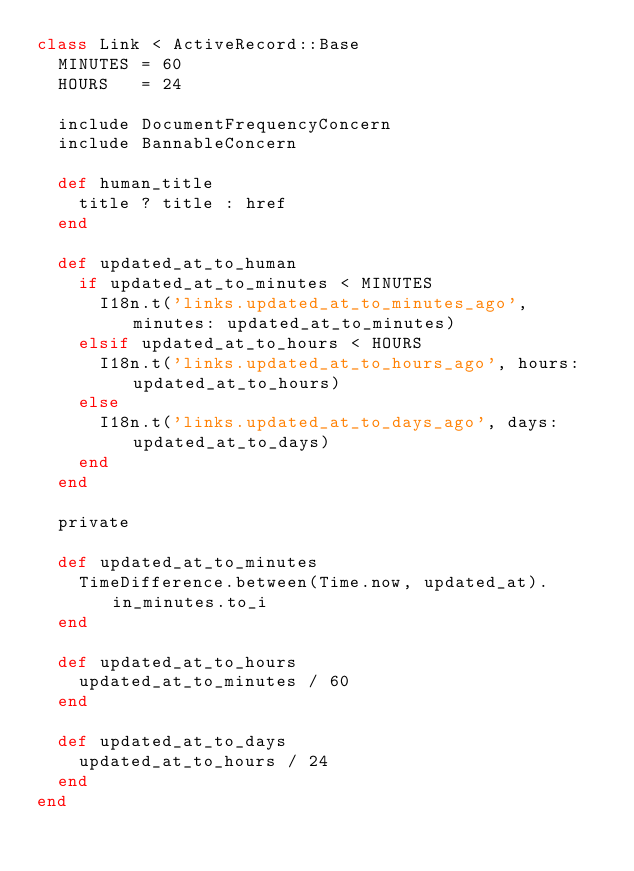Convert code to text. <code><loc_0><loc_0><loc_500><loc_500><_Ruby_>class Link < ActiveRecord::Base
  MINUTES = 60
  HOURS   = 24

  include DocumentFrequencyConcern
  include BannableConcern

  def human_title
    title ? title : href
  end

  def updated_at_to_human
    if updated_at_to_minutes < MINUTES
      I18n.t('links.updated_at_to_minutes_ago', minutes: updated_at_to_minutes)
    elsif updated_at_to_hours < HOURS
      I18n.t('links.updated_at_to_hours_ago', hours: updated_at_to_hours)
    else
      I18n.t('links.updated_at_to_days_ago', days: updated_at_to_days)
    end
  end

  private

  def updated_at_to_minutes
    TimeDifference.between(Time.now, updated_at).in_minutes.to_i
  end

  def updated_at_to_hours
    updated_at_to_minutes / 60
  end

  def updated_at_to_days
    updated_at_to_hours / 24
  end
end
</code> 